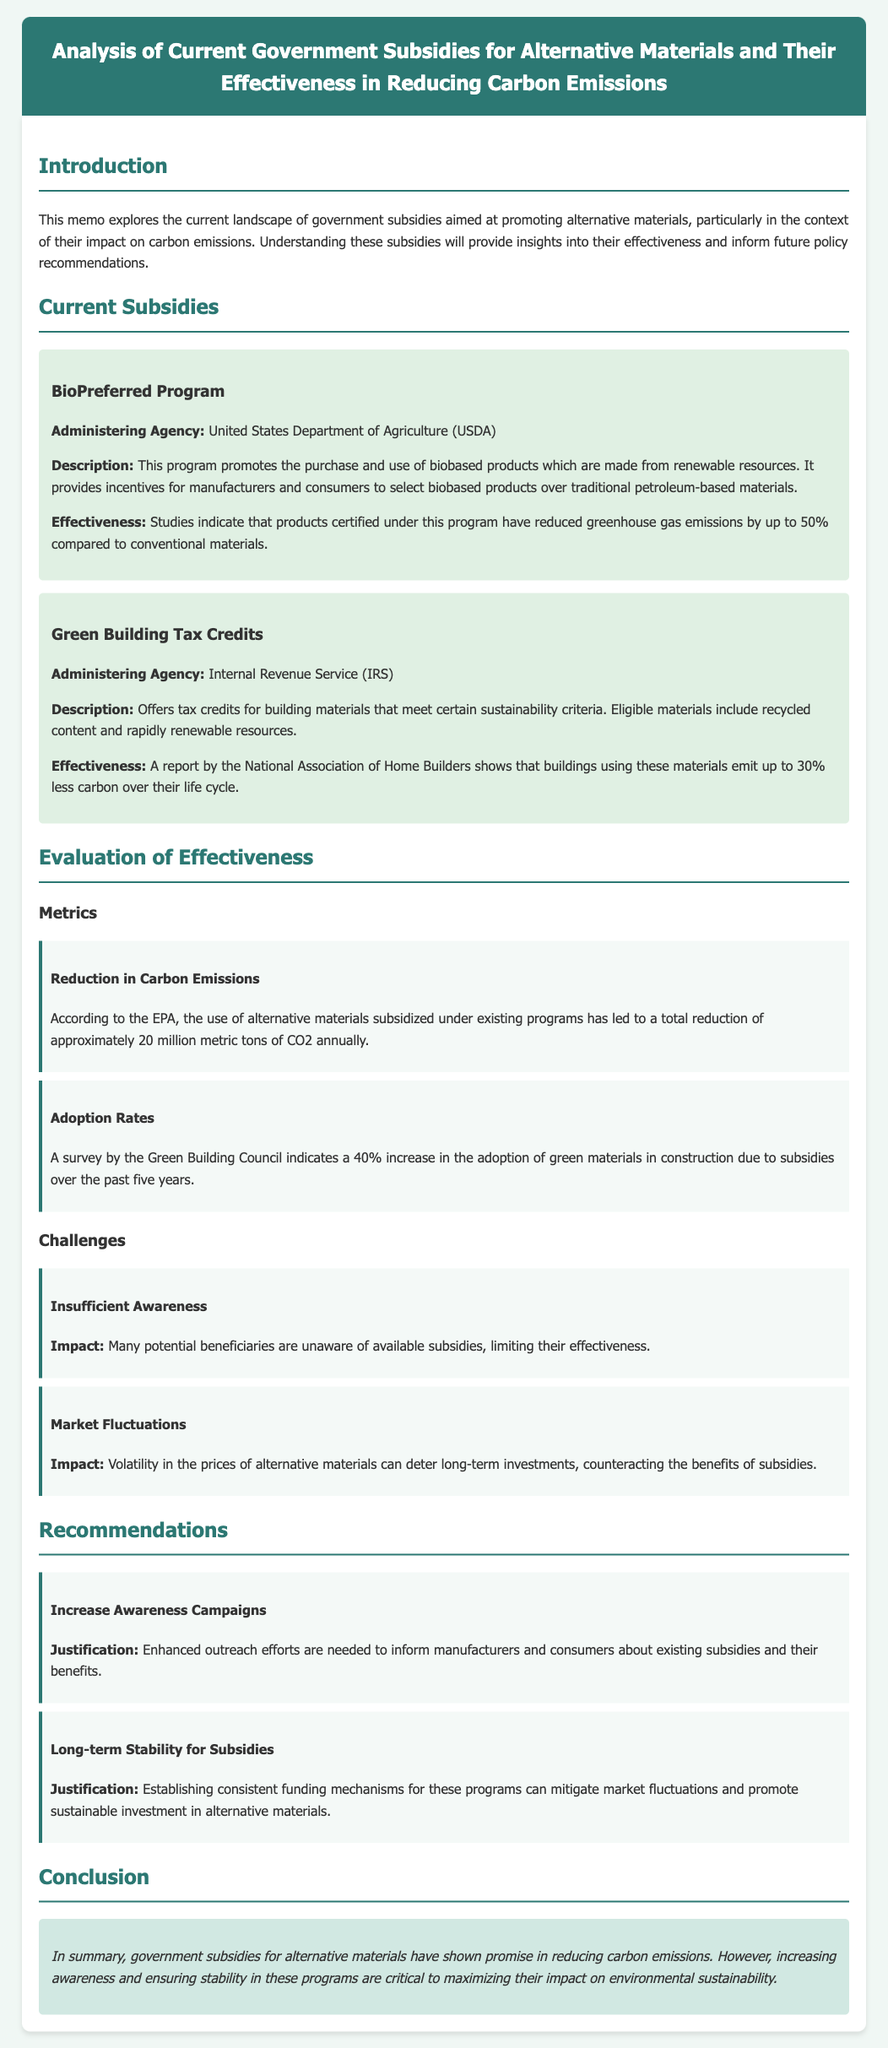What is the administering agency for the BioPreferred Program? The BioPreferred Program is administered by the United States Department of Agriculture (USDA).
Answer: United States Department of Agriculture (USDA) What percentage reduction in greenhouse gas emissions is reported for BioPreferred products? The effectiveness section states that these products have reduced greenhouse gas emissions by up to 50%.
Answer: 50% What is the annual reduction of CO2 due to alternative materials subsidized under current programs? The document cites an annual reduction of approximately 20 million metric tons of CO2 due to these materials.
Answer: 20 million metric tons What is one challenge mentioned regarding the effectiveness of current subsidies? The memo indicates that insufficient awareness among potential beneficiaries is a challenge impacting subsidy effectiveness.
Answer: Insufficient Awareness What is the proposed recommendation to increase awareness of subsidies? The document suggests enhancing outreach efforts to inform manufacturers and consumers about existing subsidies.
Answer: Increase Awareness Campaigns How much has the adoption of green materials increased in construction due to subsidies over the past five years? According to the survey by the Green Building Council, there has been a 40% increase in the adoption of green materials in construction.
Answer: 40% What type of tax credits does the Green Building Tax Credits program offer? The program offers tax credits for building materials that meet certain sustainability criteria.
Answer: Tax credits for building materials What does the conclusion highlight as critical for maximizing the impact of subsidies? The conclusion emphasizes that increasing awareness and ensuring stability in these programs are critical to maximizing their impact.
Answer: Increasing awareness and ensuring stability 